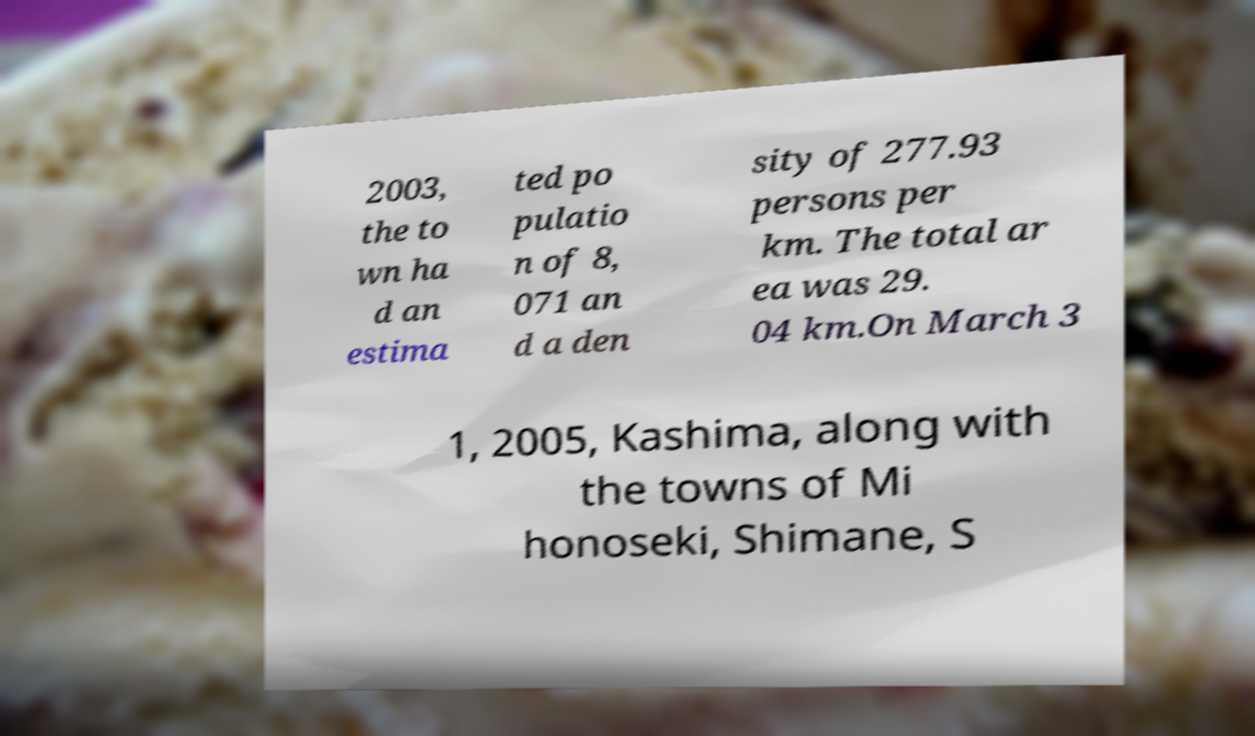Could you extract and type out the text from this image? 2003, the to wn ha d an estima ted po pulatio n of 8, 071 an d a den sity of 277.93 persons per km. The total ar ea was 29. 04 km.On March 3 1, 2005, Kashima, along with the towns of Mi honoseki, Shimane, S 